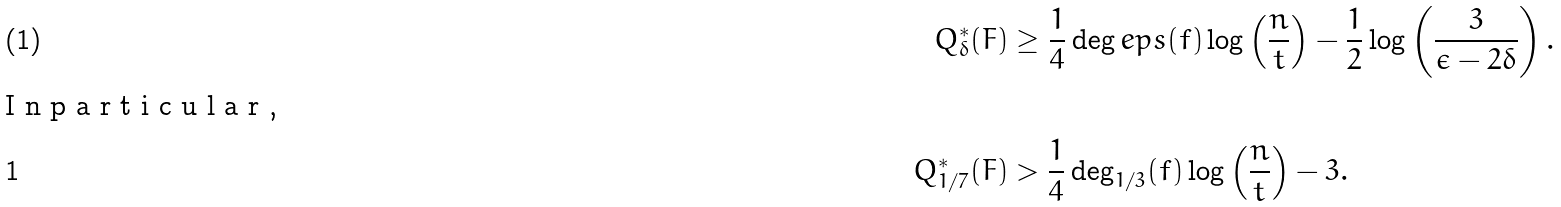Convert formula to latex. <formula><loc_0><loc_0><loc_500><loc_500>Q ^ { * } _ { \delta } ( F ) & \geq \frac { 1 } { 4 } \deg e p s ( f ) \log \left ( \frac { n } { t } \right ) - \frac { 1 } { 2 } \log \left ( \frac { 3 } { \epsilon - 2 \delta } \right ) . \intertext { I n p a r t i c u l a r , } Q ^ { * } _ { 1 / 7 } ( F ) & > \frac { 1 } { 4 } \deg _ { 1 / 3 } ( f ) \log \left ( \frac { n } { t } \right ) - 3 .</formula> 